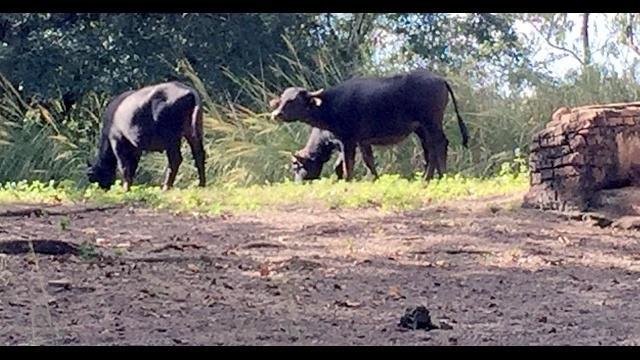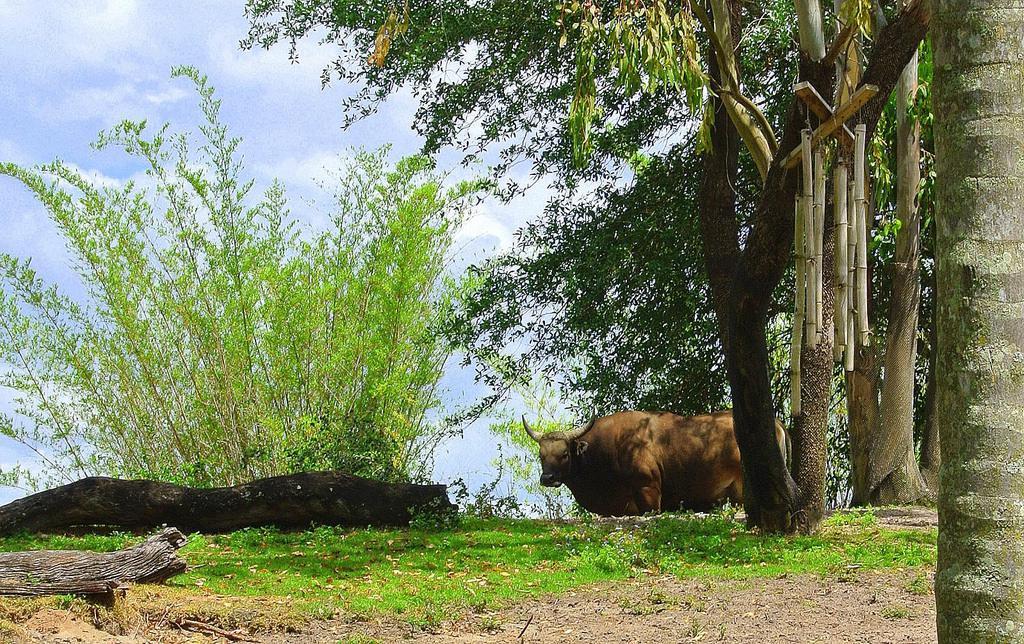The first image is the image on the left, the second image is the image on the right. Given the left and right images, does the statement "There are exactly two animals in the image on the left." hold true? Answer yes or no. No. 